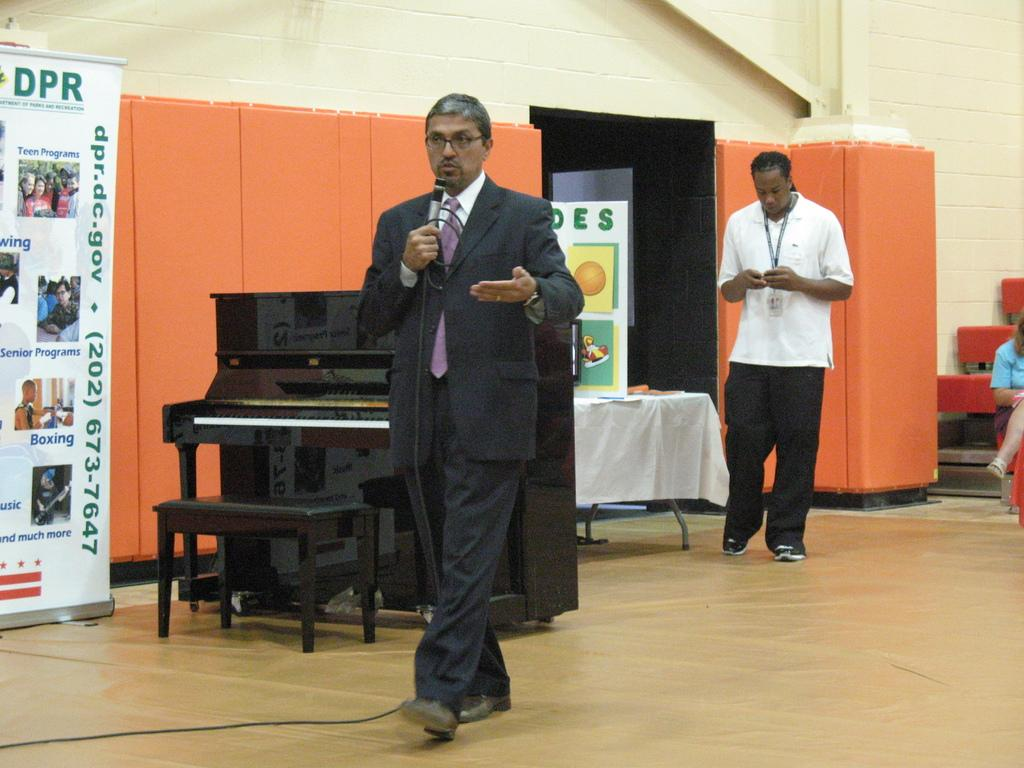What can be seen hanging in the image? There is a banner in the image. What color is the wall in the image? The wall in the image is yellow. How many people are present in the image? There are two people standing in the image. What type of furniture is visible in the image? There is a table in the image. Can you find a match on the table in the image? There is no match present on the table in the image. What type of farm animals can be seen in the image? There are no farm animals present in the image. 